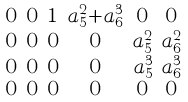<formula> <loc_0><loc_0><loc_500><loc_500>\begin{smallmatrix} 0 & 0 & 1 & a ^ { 2 } _ { 5 } + a ^ { 3 } _ { 6 } & 0 & 0 \\ 0 & 0 & 0 & 0 & a ^ { 2 } _ { 5 } & a ^ { 2 } _ { 6 } \\ 0 & 0 & 0 & 0 & a ^ { 3 } _ { 5 } & a ^ { 3 } _ { 6 } \\ 0 & 0 & 0 & 0 & 0 & 0 \end{smallmatrix}</formula> 